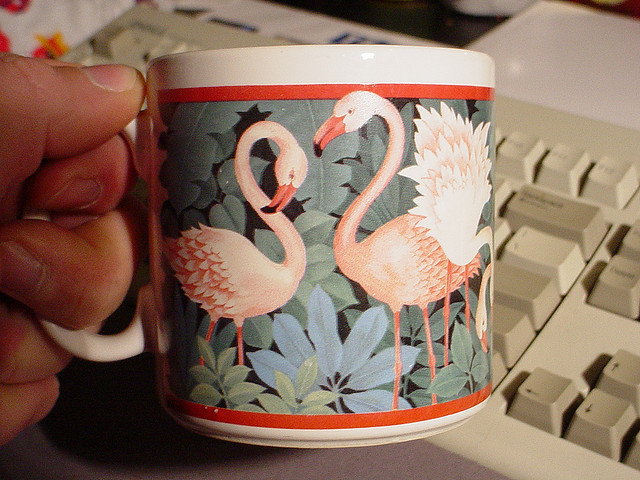<image>What flowers are written on the side of the cup? I don't know what flowers are written on the side of the cup. What flowers are written on the side of the cup? I don't know what flowers are written on the side of the cup. It can be seen leaves, blue and green, ivy or none. 